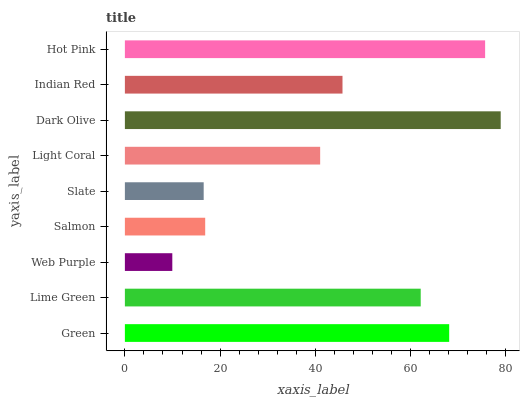Is Web Purple the minimum?
Answer yes or no. Yes. Is Dark Olive the maximum?
Answer yes or no. Yes. Is Lime Green the minimum?
Answer yes or no. No. Is Lime Green the maximum?
Answer yes or no. No. Is Green greater than Lime Green?
Answer yes or no. Yes. Is Lime Green less than Green?
Answer yes or no. Yes. Is Lime Green greater than Green?
Answer yes or no. No. Is Green less than Lime Green?
Answer yes or no. No. Is Indian Red the high median?
Answer yes or no. Yes. Is Indian Red the low median?
Answer yes or no. Yes. Is Lime Green the high median?
Answer yes or no. No. Is Green the low median?
Answer yes or no. No. 